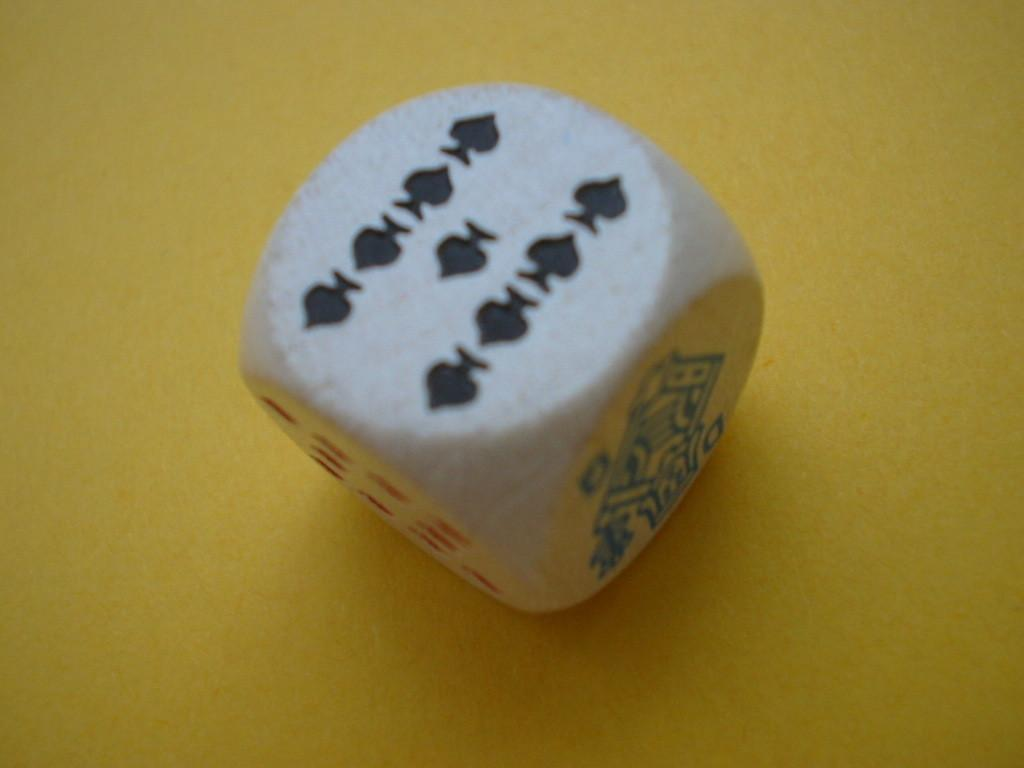What object is the main focus of the image? There is a white dice in the image. What colors are present on the dice? The dice has black and red color symbols. What is the color of the surface on which the dice is placed? The dice is placed on a yellow surface. What type of creature is sitting on the dice in the image? There is no creature present on the dice or in the image. What kind of lipstick can be seen on the dice in the image? There is no lipstick or any cosmetic product present on the dice or in the image. 